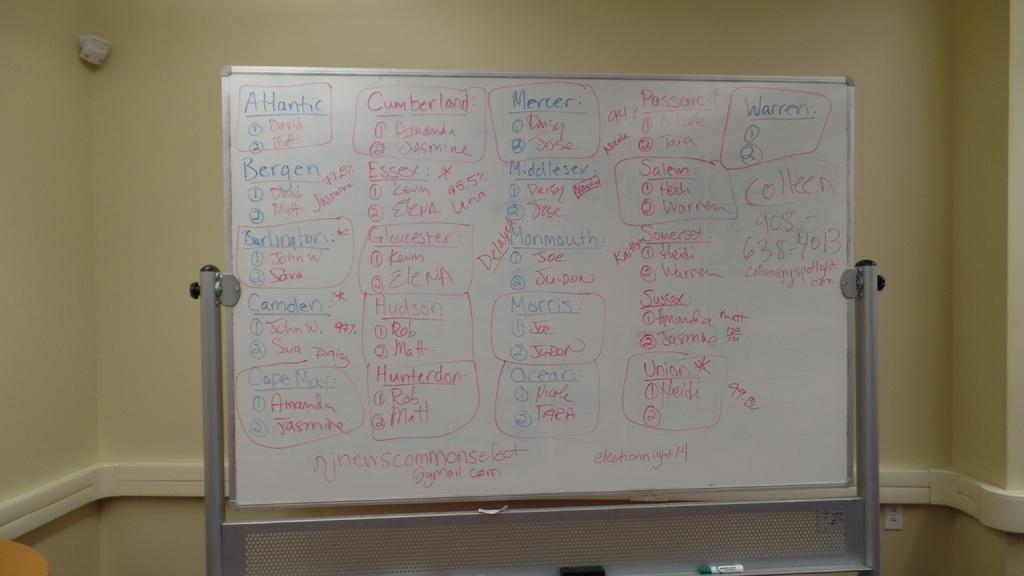<image>
Render a clear and concise summary of the photo. A white board with writing all over it divided into categories including Atlantic and Cumberland. 